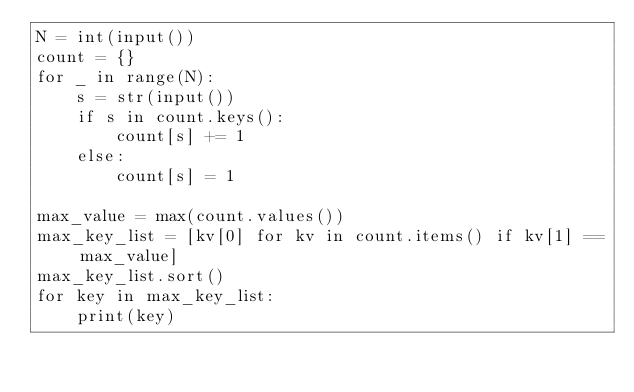<code> <loc_0><loc_0><loc_500><loc_500><_Python_>N = int(input())
count = {}
for _ in range(N):
    s = str(input())
    if s in count.keys():
        count[s] += 1
    else:
        count[s] = 1

max_value = max(count.values())
max_key_list = [kv[0] for kv in count.items() if kv[1] == max_value]
max_key_list.sort()
for key in max_key_list:
    print(key)
</code> 